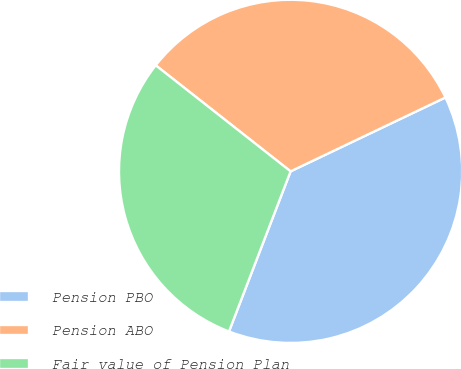<chart> <loc_0><loc_0><loc_500><loc_500><pie_chart><fcel>Pension PBO<fcel>Pension ABO<fcel>Fair value of Pension Plan<nl><fcel>37.93%<fcel>32.31%<fcel>29.76%<nl></chart> 